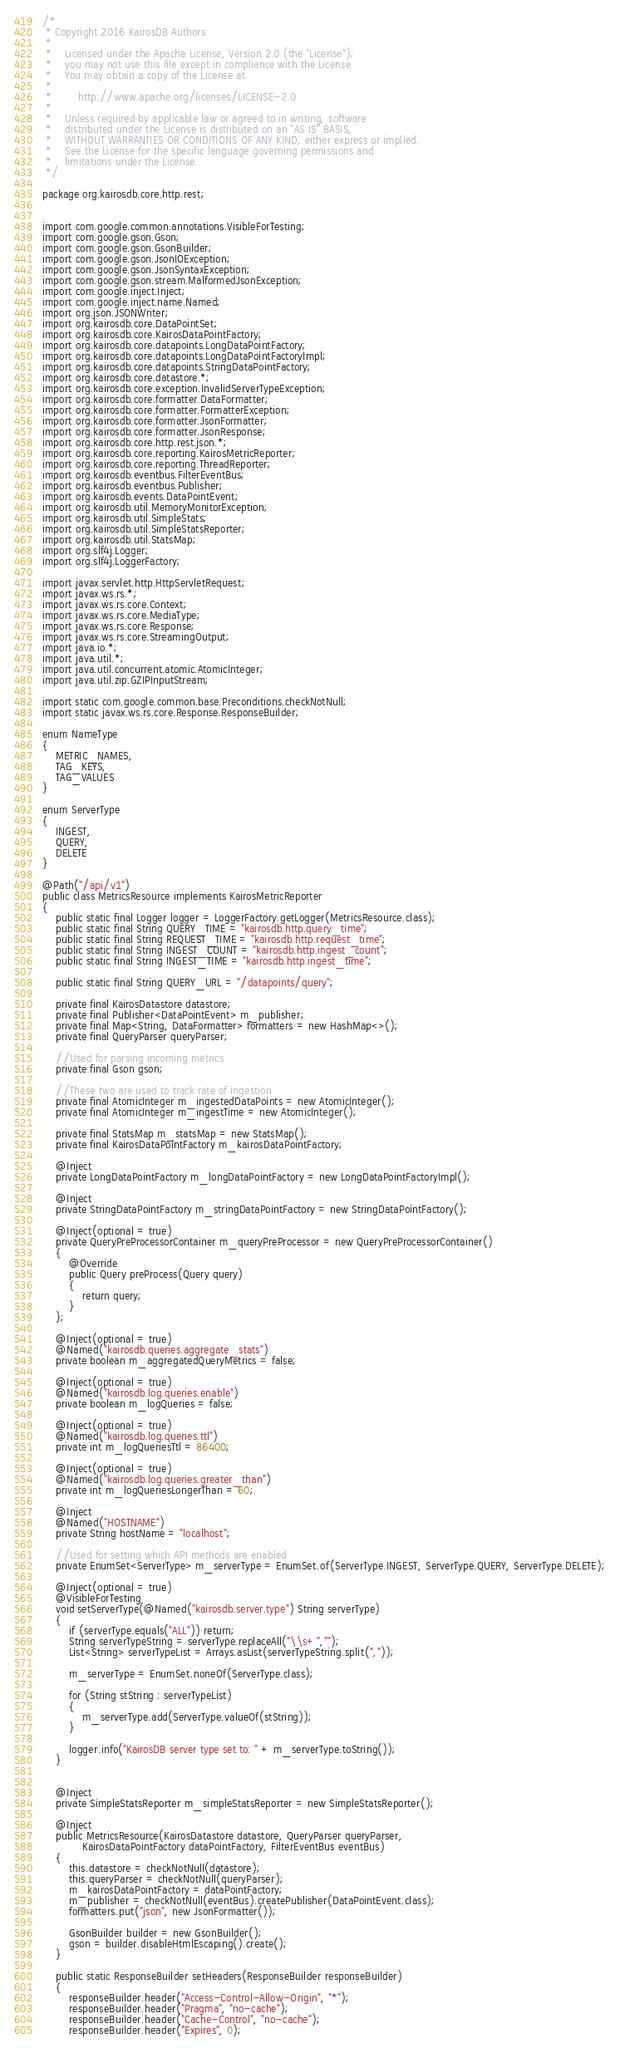Convert code to text. <code><loc_0><loc_0><loc_500><loc_500><_Java_>/*
 * Copyright 2016 KairosDB Authors
 *
 *    Licensed under the Apache License, Version 2.0 (the "License");
 *    you may not use this file except in compliance with the License.
 *    You may obtain a copy of the License at
 *
 *        http://www.apache.org/licenses/LICENSE-2.0
 *
 *    Unless required by applicable law or agreed to in writing, software
 *    distributed under the License is distributed on an "AS IS" BASIS,
 *    WITHOUT WARRANTIES OR CONDITIONS OF ANY KIND, either express or implied.
 *    See the License for the specific language governing permissions and
 *    limitations under the License.
 */

package org.kairosdb.core.http.rest;


import com.google.common.annotations.VisibleForTesting;
import com.google.gson.Gson;
import com.google.gson.GsonBuilder;
import com.google.gson.JsonIOException;
import com.google.gson.JsonSyntaxException;
import com.google.gson.stream.MalformedJsonException;
import com.google.inject.Inject;
import com.google.inject.name.Named;
import org.json.JSONWriter;
import org.kairosdb.core.DataPointSet;
import org.kairosdb.core.KairosDataPointFactory;
import org.kairosdb.core.datapoints.LongDataPointFactory;
import org.kairosdb.core.datapoints.LongDataPointFactoryImpl;
import org.kairosdb.core.datapoints.StringDataPointFactory;
import org.kairosdb.core.datastore.*;
import org.kairosdb.core.exception.InvalidServerTypeException;
import org.kairosdb.core.formatter.DataFormatter;
import org.kairosdb.core.formatter.FormatterException;
import org.kairosdb.core.formatter.JsonFormatter;
import org.kairosdb.core.formatter.JsonResponse;
import org.kairosdb.core.http.rest.json.*;
import org.kairosdb.core.reporting.KairosMetricReporter;
import org.kairosdb.core.reporting.ThreadReporter;
import org.kairosdb.eventbus.FilterEventBus;
import org.kairosdb.eventbus.Publisher;
import org.kairosdb.events.DataPointEvent;
import org.kairosdb.util.MemoryMonitorException;
import org.kairosdb.util.SimpleStats;
import org.kairosdb.util.SimpleStatsReporter;
import org.kairosdb.util.StatsMap;
import org.slf4j.Logger;
import org.slf4j.LoggerFactory;

import javax.servlet.http.HttpServletRequest;
import javax.ws.rs.*;
import javax.ws.rs.core.Context;
import javax.ws.rs.core.MediaType;
import javax.ws.rs.core.Response;
import javax.ws.rs.core.StreamingOutput;
import java.io.*;
import java.util.*;
import java.util.concurrent.atomic.AtomicInteger;
import java.util.zip.GZIPInputStream;

import static com.google.common.base.Preconditions.checkNotNull;
import static javax.ws.rs.core.Response.ResponseBuilder;

enum NameType
{
	METRIC_NAMES,
	TAG_KEYS,
	TAG_VALUES
}

enum ServerType
{
	INGEST,
	QUERY,
	DELETE
}

@Path("/api/v1")
public class MetricsResource implements KairosMetricReporter
{
	public static final Logger logger = LoggerFactory.getLogger(MetricsResource.class);
	public static final String QUERY_TIME = "kairosdb.http.query_time";
	public static final String REQUEST_TIME = "kairosdb.http.request_time";
	public static final String INGEST_COUNT = "kairosdb.http.ingest_count";
	public static final String INGEST_TIME = "kairosdb.http.ingest_time";

	public static final String QUERY_URL = "/datapoints/query";

	private final KairosDatastore datastore;
	private final Publisher<DataPointEvent> m_publisher;
	private final Map<String, DataFormatter> formatters = new HashMap<>();
	private final QueryParser queryParser;

	//Used for parsing incoming metrics
	private final Gson gson;

	//These two are used to track rate of ingestion
	private final AtomicInteger m_ingestedDataPoints = new AtomicInteger();
	private final AtomicInteger m_ingestTime = new AtomicInteger();

	private final StatsMap m_statsMap = new StatsMap();
	private final KairosDataPointFactory m_kairosDataPointFactory;

	@Inject
	private LongDataPointFactory m_longDataPointFactory = new LongDataPointFactoryImpl();

	@Inject
	private StringDataPointFactory m_stringDataPointFactory = new StringDataPointFactory();

	@Inject(optional = true)
	private QueryPreProcessorContainer m_queryPreProcessor = new QueryPreProcessorContainer()
	{
		@Override
		public Query preProcess(Query query)
		{
			return query;
		}
	};

	@Inject(optional = true)
	@Named("kairosdb.queries.aggregate_stats")
	private boolean m_aggregatedQueryMetrics = false;

	@Inject(optional = true)
	@Named("kairosdb.log.queries.enable")
	private boolean m_logQueries = false;

	@Inject(optional = true)
	@Named("kairosdb.log.queries.ttl")
	private int m_logQueriesTtl = 86400;

	@Inject(optional = true)
	@Named("kairosdb.log.queries.greater_than")
	private int m_logQueriesLongerThan = 60;

	@Inject
	@Named("HOSTNAME")
	private String hostName = "localhost";

	//Used for setting which API methods are enabled
	private EnumSet<ServerType> m_serverType = EnumSet.of(ServerType.INGEST, ServerType.QUERY, ServerType.DELETE);

	@Inject(optional = true)
	@VisibleForTesting
	void setServerType(@Named("kairosdb.server.type") String serverType)
	{
		if (serverType.equals("ALL")) return;
		String serverTypeString = serverType.replaceAll("\\s+","");
		List<String> serverTypeList = Arrays.asList(serverTypeString.split(","));

		m_serverType = EnumSet.noneOf(ServerType.class);

		for (String stString : serverTypeList)
		{
			m_serverType.add(ServerType.valueOf(stString));
		}

		logger.info("KairosDB server type set to: " + m_serverType.toString());
	}


	@Inject
	private SimpleStatsReporter m_simpleStatsReporter = new SimpleStatsReporter();

	@Inject
	public MetricsResource(KairosDatastore datastore, QueryParser queryParser,
			KairosDataPointFactory dataPointFactory, FilterEventBus eventBus)
	{
		this.datastore = checkNotNull(datastore);
		this.queryParser = checkNotNull(queryParser);
		m_kairosDataPointFactory = dataPointFactory;
		m_publisher = checkNotNull(eventBus).createPublisher(DataPointEvent.class);
		formatters.put("json", new JsonFormatter());

		GsonBuilder builder = new GsonBuilder();
		gson = builder.disableHtmlEscaping().create();
	}

	public static ResponseBuilder setHeaders(ResponseBuilder responseBuilder)
	{
		responseBuilder.header("Access-Control-Allow-Origin", "*");
		responseBuilder.header("Pragma", "no-cache");
		responseBuilder.header("Cache-Control", "no-cache");
		responseBuilder.header("Expires", 0);
</code> 